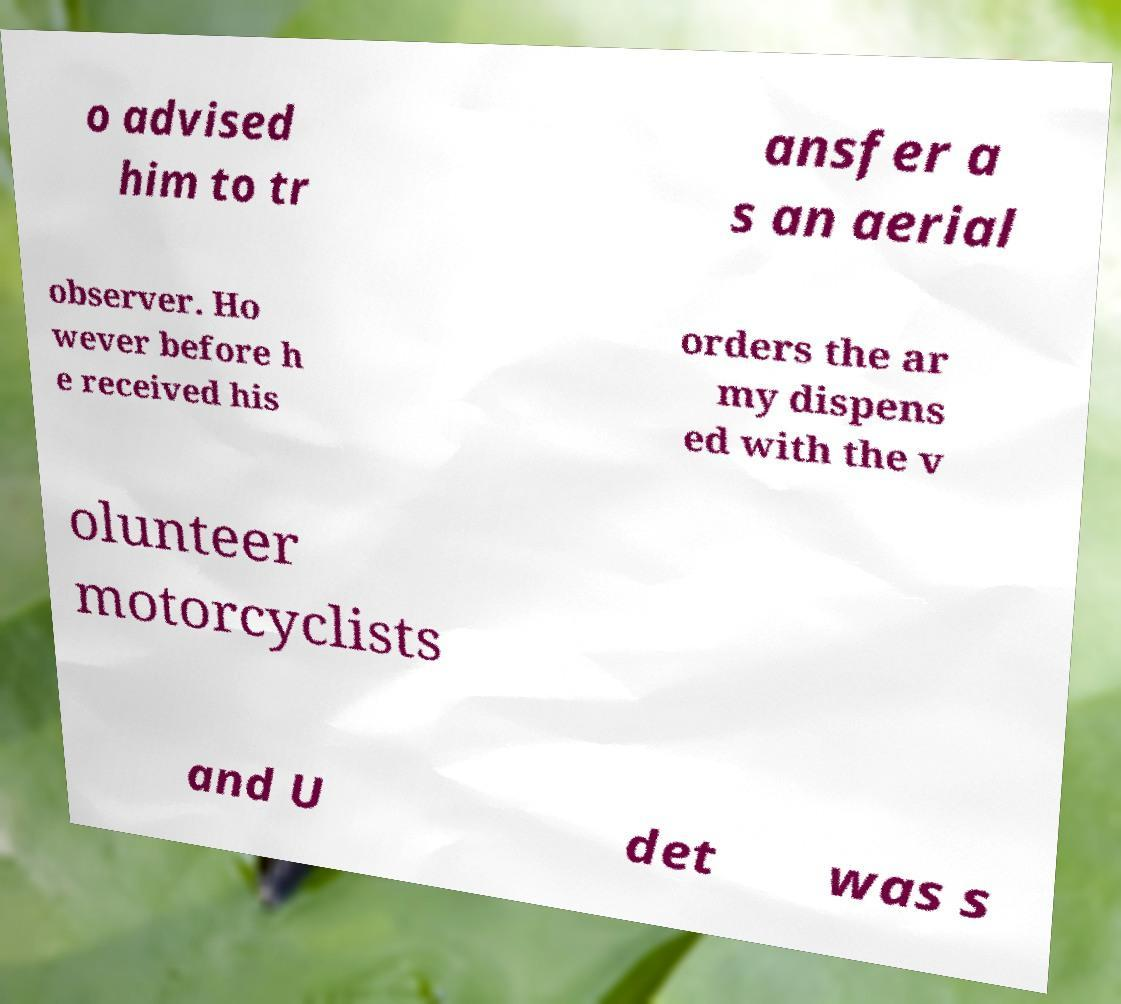For documentation purposes, I need the text within this image transcribed. Could you provide that? o advised him to tr ansfer a s an aerial observer. Ho wever before h e received his orders the ar my dispens ed with the v olunteer motorcyclists and U det was s 